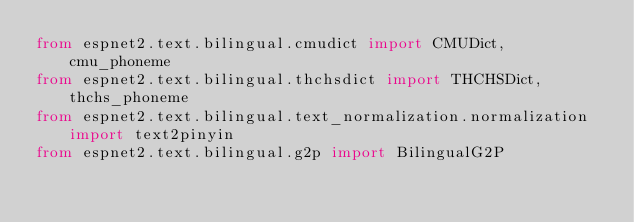<code> <loc_0><loc_0><loc_500><loc_500><_Python_>from espnet2.text.bilingual.cmudict import CMUDict, cmu_phoneme
from espnet2.text.bilingual.thchsdict import THCHSDict, thchs_phoneme
from espnet2.text.bilingual.text_normalization.normalization import text2pinyin
from espnet2.text.bilingual.g2p import BilingualG2P</code> 